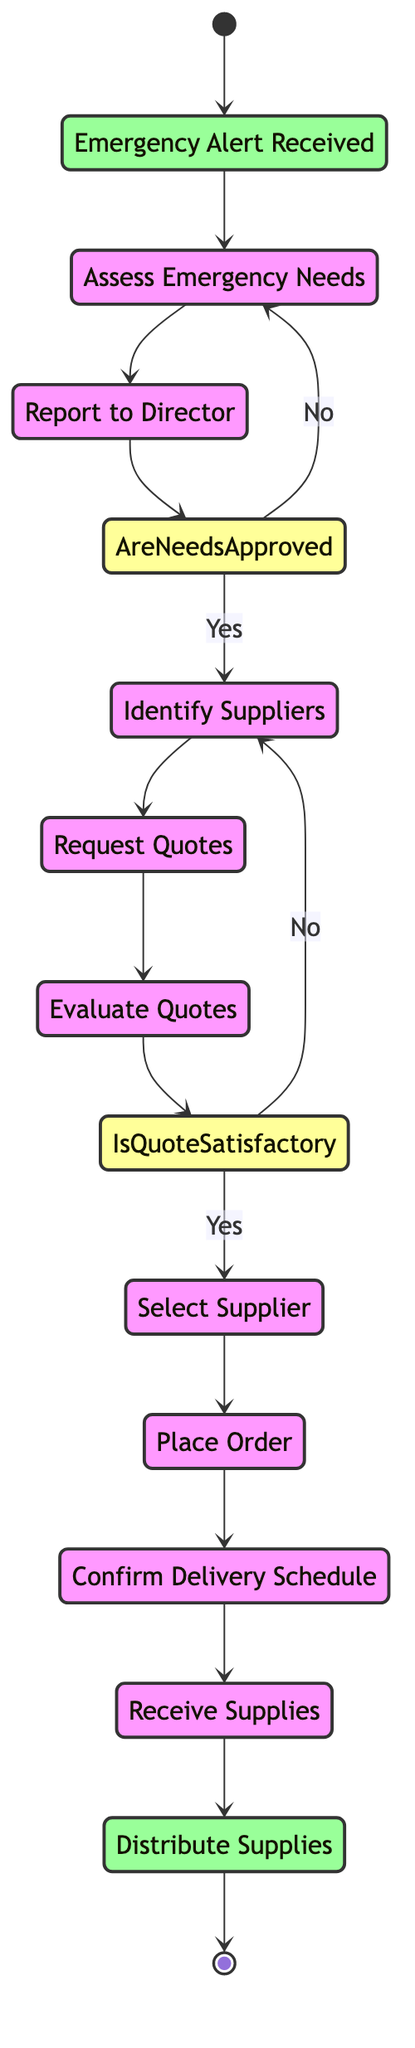What is the starting point of the process? The diagram begins with the node labeled "Emergency Alert Received," which indicates the initiation of the procurement process for emergency supplies upon receiving an alert.
Answer: Emergency Alert Received How many main activities are represented in the diagram? The diagram lists ten main activities, including tasks like assessing needs, identifying suppliers, and distributing supplies, which are all necessary for the procurement process.
Answer: Ten What decision point follows the "Report to Director" activity? The decision point that follows "Report to Director" is "Are Needs Approved?" which determines the next steps based on whether the assessed needs are accepted by the Director.
Answer: Are Needs Approved Which actor is responsible for confirming the delivery schedule? The "Project Manager" is designated to coordinate with the supplier and confirm the delivery date and time after placing the order.
Answer: Project Manager What is the consequence of a "No" answer at the "Are Needs Approved?" decision? If the answer is "No," the process returns to the "Assess Emergency Needs" activity, indicating that further evaluation of needs is necessary before moving forward.
Answer: Assess Emergency Needs What happens after receiving the supplies? Following the reception of supplies, the next step is "Distribute Supplies," where the Disaster Response Team ensures that the supplies are delivered to the emergency site.
Answer: Distribute Supplies What is the last step of the procurement process? The final step in the procurement process is depicted as "Supplies Delivered and Distributed," marking the successful completion of the supply chain.
Answer: Supplies Delivered and Distributed What activity comes immediately after evaluating quotes? Directly after the "Evaluate Quotes" activity, the process enters the decision point labeled "Is Quote Satisfactory?" where the quotes received are assessed for acceptance.
Answer: Is Quote Satisfactory Who is involved in selecting the supplier? The "Procurement Team" is tasked with choosing the supplier that best meets the established criteria after evaluating the quotes.
Answer: Procurement Team 